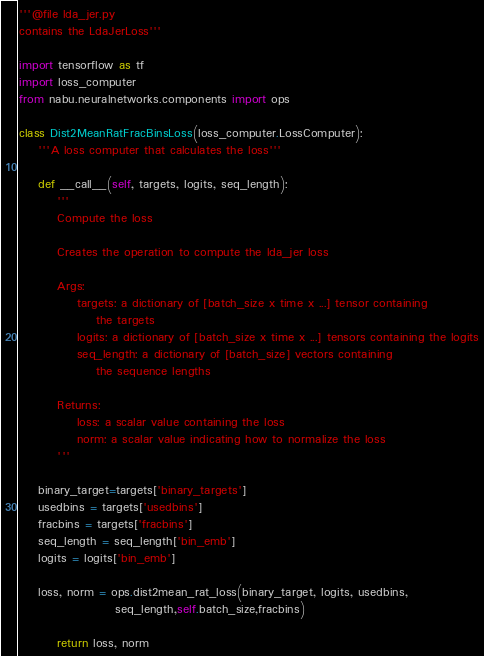Convert code to text. <code><loc_0><loc_0><loc_500><loc_500><_Python_>'''@file lda_jer.py
contains the LdaJerLoss'''

import tensorflow as tf
import loss_computer
from nabu.neuralnetworks.components import ops

class Dist2MeanRatFracBinsLoss(loss_computer.LossComputer):
    '''A loss computer that calculates the loss'''

    def __call__(self, targets, logits, seq_length):
        '''
        Compute the loss

        Creates the operation to compute the lda_jer loss

        Args:
            targets: a dictionary of [batch_size x time x ...] tensor containing
                the targets
            logits: a dictionary of [batch_size x time x ...] tensors containing the logits
            seq_length: a dictionary of [batch_size] vectors containing
                the sequence lengths

        Returns:
            loss: a scalar value containing the loss
            norm: a scalar value indicating how to normalize the loss
        '''
                       
	binary_target=targets['binary_targets']            
	usedbins = targets['usedbins']          
	fracbins = targets['fracbins']
	seq_length = seq_length['bin_emb']
	logits = logits['bin_emb']
		    
	loss, norm = ops.dist2mean_rat_loss(binary_target, logits, usedbins, 
					seq_length,self.batch_size,fracbins)
            
        return loss, norm
</code> 